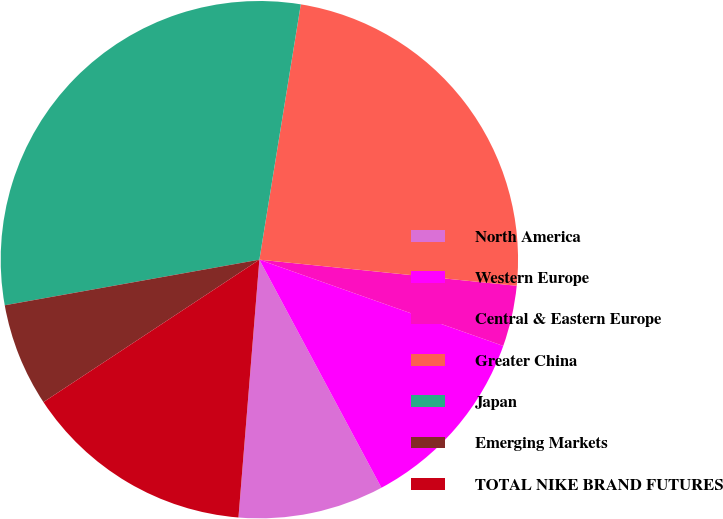Convert chart. <chart><loc_0><loc_0><loc_500><loc_500><pie_chart><fcel>North America<fcel>Western Europe<fcel>Central & Eastern Europe<fcel>Greater China<fcel>Japan<fcel>Emerging Markets<fcel>TOTAL NIKE BRAND FUTURES<nl><fcel>9.11%<fcel>11.77%<fcel>3.8%<fcel>24.05%<fcel>30.38%<fcel>6.46%<fcel>14.43%<nl></chart> 